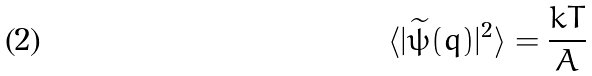Convert formula to latex. <formula><loc_0><loc_0><loc_500><loc_500>\langle | \widetilde { \psi } ( q ) | ^ { 2 } \rangle = \frac { k T } { A }</formula> 